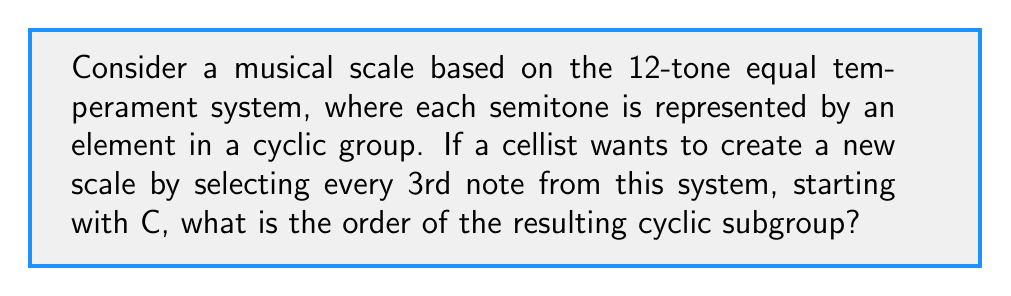What is the answer to this math problem? Let's approach this step-by-step:

1) In the 12-tone equal temperament system, we have 12 distinct pitches in an octave. This can be represented by the cyclic group $C_{12}$ of order 12.

2) The elements of $C_{12}$ can be labeled as $\{0, 1, 2, ..., 11\}$, where 0 represents C, 1 represents C#, and so on.

3) The new scale is created by selecting every 3rd note. This is equivalent to considering the subgroup generated by the element 3 in $C_{12}$.

4) To find the order of this subgroup, we need to determine the smallest positive integer $n$ such that:

   $3n \equiv 0 \pmod{12}$

5) We can solve this by listing the multiples of 3 modulo 12:
   
   $3 \equiv 3 \pmod{12}$
   $6 \equiv 6 \pmod{12}$
   $9 \equiv 9 \pmod{12}$
   $12 \equiv 0 \pmod{12}$

6) We see that when $n = 4$, we get $3n = 12 \equiv 0 \pmod{12}$.

7) Therefore, the order of the subgroup is 4.

8) Musically, this means the new scale will have 4 distinct notes before repeating. These notes are:
   
   C (0), D# (3), F# (6), A (9)

This scale is known as the diminished seventh chord, which is indeed a 4-note scale often used in cello repertoire.
Answer: The order of the resulting cyclic subgroup is 4. 